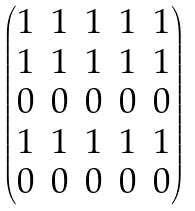Convert formula to latex. <formula><loc_0><loc_0><loc_500><loc_500>\begin{pmatrix} 1 & 1 & 1 & 1 & 1 \\ 1 & 1 & 1 & 1 & 1 \\ 0 & 0 & 0 & 0 & 0 \\ 1 & 1 & 1 & 1 & 1 \\ 0 & 0 & 0 & 0 & 0 \\ \end{pmatrix}</formula> 